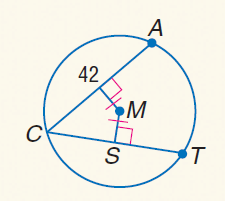Answer the mathemtical geometry problem and directly provide the correct option letter.
Question: Find S C.
Choices: A: 3 B: 7 C: 21 D: 42 C 